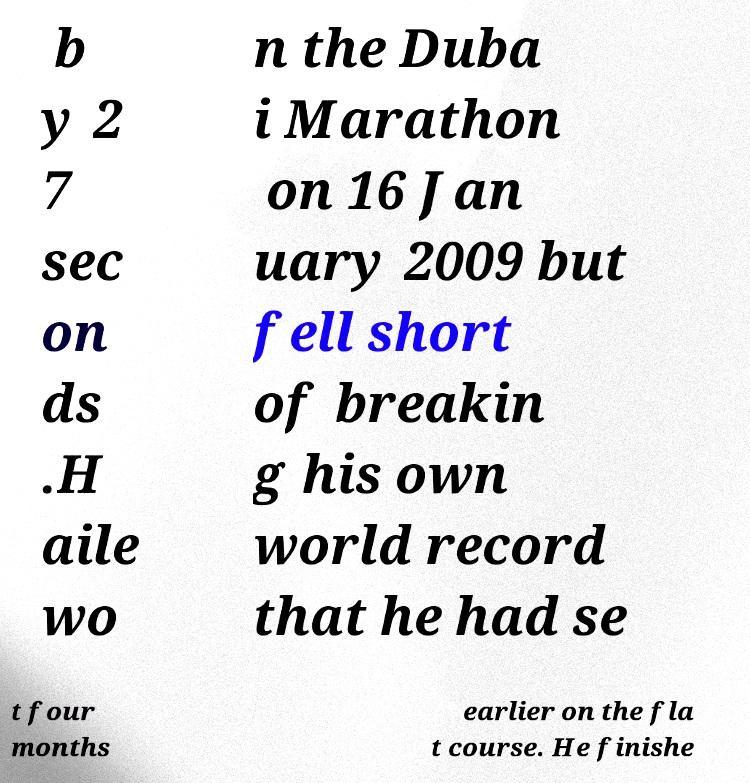For documentation purposes, I need the text within this image transcribed. Could you provide that? b y 2 7 sec on ds .H aile wo n the Duba i Marathon on 16 Jan uary 2009 but fell short of breakin g his own world record that he had se t four months earlier on the fla t course. He finishe 